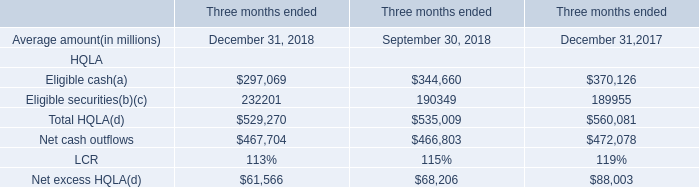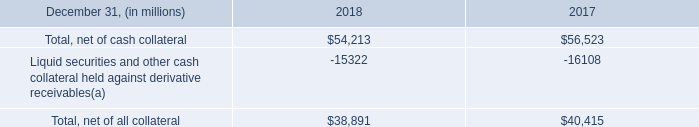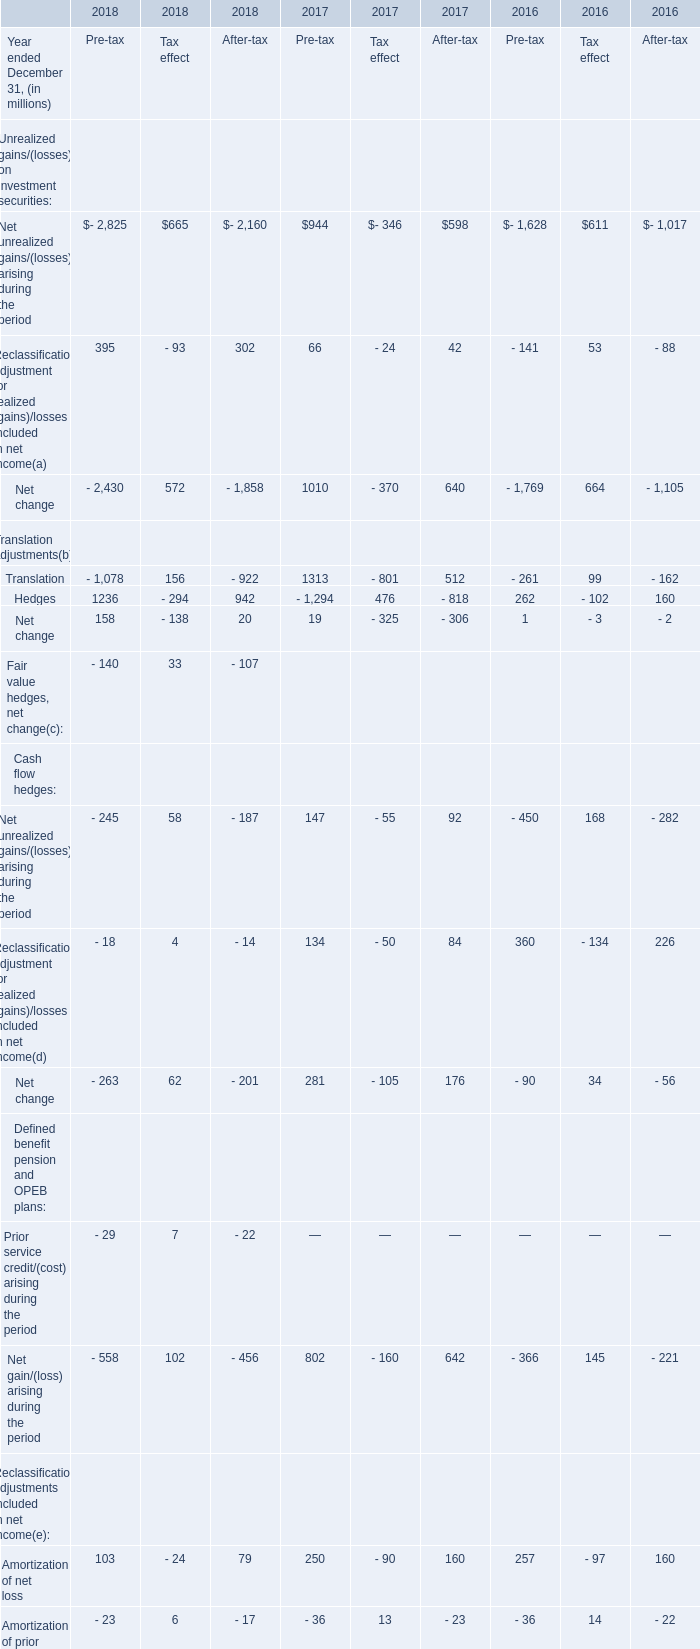What was the average value of Translation, Hedges, Net change of Translation adjustmentsin 2018 for Pre-tax ? (in million) 
Computations: (((-1078 + 1236) + 158) / 3)
Answer: 105.33333. 